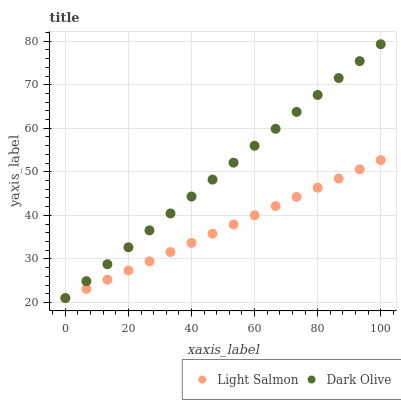Does Light Salmon have the minimum area under the curve?
Answer yes or no. Yes. Does Dark Olive have the maximum area under the curve?
Answer yes or no. Yes. Does Dark Olive have the minimum area under the curve?
Answer yes or no. No. Is Light Salmon the smoothest?
Answer yes or no. Yes. Is Dark Olive the roughest?
Answer yes or no. Yes. Is Dark Olive the smoothest?
Answer yes or no. No. Does Light Salmon have the lowest value?
Answer yes or no. Yes. Does Dark Olive have the highest value?
Answer yes or no. Yes. Does Light Salmon intersect Dark Olive?
Answer yes or no. Yes. Is Light Salmon less than Dark Olive?
Answer yes or no. No. Is Light Salmon greater than Dark Olive?
Answer yes or no. No. 